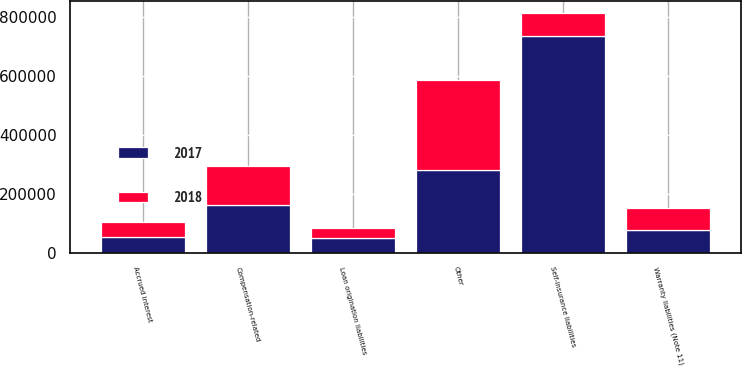Convert chart to OTSL. <chart><loc_0><loc_0><loc_500><loc_500><stacked_bar_chart><ecel><fcel>Self-insurance liabilities<fcel>Compensation-related<fcel>Warranty liabilities (Note 11)<fcel>Accrued interest<fcel>Loan origination liabilities<fcel>Other<nl><fcel>2017<fcel>737013<fcel>161068<fcel>79154<fcel>52521<fcel>50282<fcel>280445<nl><fcel>2018<fcel>79154<fcel>134008<fcel>72709<fcel>50620<fcel>34641<fcel>305543<nl></chart> 